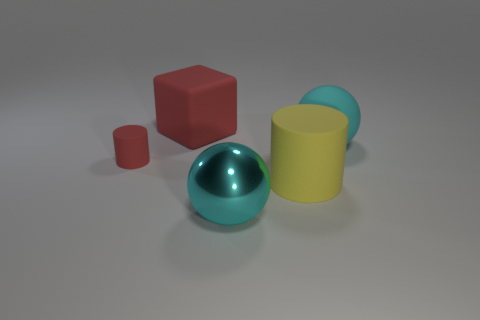Does the large metal ball have the same color as the large object right of the yellow matte cylinder?
Offer a very short reply. Yes. The object that is the same color as the large matte block is what size?
Make the answer very short. Small. What number of other objects are there of the same shape as the large metallic thing?
Keep it short and to the point. 1. What number of things are either tiny red things or small cyan objects?
Ensure brevity in your answer.  1. Does the metallic thing have the same color as the large matte sphere?
Your response must be concise. Yes. Is there anything else that has the same size as the red rubber cylinder?
Keep it short and to the point. No. There is a cyan thing behind the large object that is in front of the big matte cylinder; what shape is it?
Your response must be concise. Sphere. Is the number of small cyan matte cubes less than the number of red matte cubes?
Keep it short and to the point. Yes. What is the size of the matte object that is both in front of the large cube and on the left side of the big yellow matte object?
Your answer should be very brief. Small. Do the yellow matte thing and the metal sphere have the same size?
Give a very brief answer. Yes. 